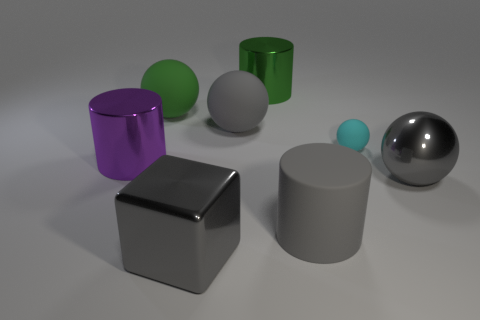Add 1 cyan spheres. How many objects exist? 9 Subtract all cylinders. How many objects are left? 5 Subtract all purple cylinders. Subtract all big gray things. How many objects are left? 3 Add 1 purple metallic objects. How many purple metallic objects are left? 2 Add 2 big metallic things. How many big metallic things exist? 6 Subtract 1 green balls. How many objects are left? 7 